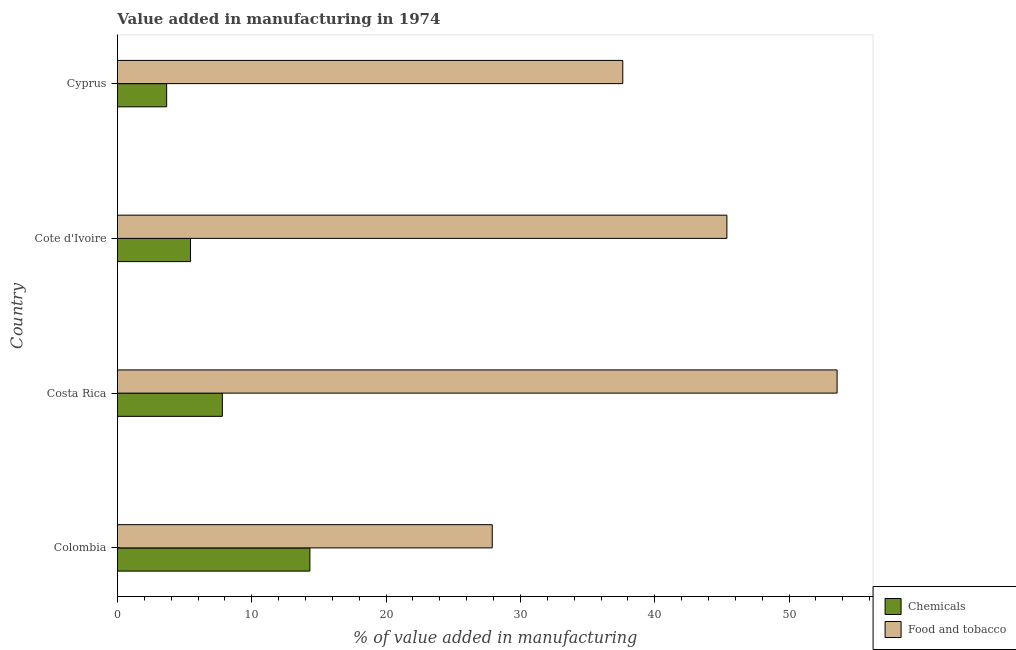How many groups of bars are there?
Your answer should be very brief. 4. Are the number of bars per tick equal to the number of legend labels?
Offer a terse response. Yes. How many bars are there on the 2nd tick from the top?
Your answer should be very brief. 2. How many bars are there on the 2nd tick from the bottom?
Provide a succinct answer. 2. What is the label of the 4th group of bars from the top?
Keep it short and to the point. Colombia. What is the value added by manufacturing food and tobacco in Cote d'Ivoire?
Provide a succinct answer. 45.37. Across all countries, what is the maximum value added by  manufacturing chemicals?
Provide a succinct answer. 14.33. Across all countries, what is the minimum value added by manufacturing food and tobacco?
Keep it short and to the point. 27.9. What is the total value added by  manufacturing chemicals in the graph?
Provide a short and direct response. 31.25. What is the difference between the value added by  manufacturing chemicals in Colombia and that in Costa Rica?
Give a very brief answer. 6.52. What is the difference between the value added by manufacturing food and tobacco in Costa Rica and the value added by  manufacturing chemicals in Cote d'Ivoire?
Your answer should be very brief. 48.13. What is the average value added by manufacturing food and tobacco per country?
Your response must be concise. 41.11. What is the difference between the value added by  manufacturing chemicals and value added by manufacturing food and tobacco in Cyprus?
Offer a very short reply. -33.95. What is the ratio of the value added by manufacturing food and tobacco in Cote d'Ivoire to that in Cyprus?
Keep it short and to the point. 1.21. Is the difference between the value added by  manufacturing chemicals in Colombia and Costa Rica greater than the difference between the value added by manufacturing food and tobacco in Colombia and Costa Rica?
Ensure brevity in your answer.  Yes. What is the difference between the highest and the second highest value added by  manufacturing chemicals?
Make the answer very short. 6.52. What is the difference between the highest and the lowest value added by manufacturing food and tobacco?
Your response must be concise. 25.67. Is the sum of the value added by  manufacturing chemicals in Cote d'Ivoire and Cyprus greater than the maximum value added by manufacturing food and tobacco across all countries?
Ensure brevity in your answer.  No. What does the 2nd bar from the top in Costa Rica represents?
Your answer should be compact. Chemicals. What does the 1st bar from the bottom in Costa Rica represents?
Keep it short and to the point. Chemicals. How many bars are there?
Provide a short and direct response. 8. Are all the bars in the graph horizontal?
Your response must be concise. Yes. How many countries are there in the graph?
Ensure brevity in your answer.  4. What is the difference between two consecutive major ticks on the X-axis?
Your response must be concise. 10. Does the graph contain any zero values?
Keep it short and to the point. No. How many legend labels are there?
Your answer should be very brief. 2. How are the legend labels stacked?
Offer a terse response. Vertical. What is the title of the graph?
Offer a very short reply. Value added in manufacturing in 1974. What is the label or title of the X-axis?
Your response must be concise. % of value added in manufacturing. What is the % of value added in manufacturing in Chemicals in Colombia?
Your response must be concise. 14.33. What is the % of value added in manufacturing of Food and tobacco in Colombia?
Your response must be concise. 27.9. What is the % of value added in manufacturing in Chemicals in Costa Rica?
Provide a succinct answer. 7.81. What is the % of value added in manufacturing in Food and tobacco in Costa Rica?
Offer a terse response. 53.57. What is the % of value added in manufacturing of Chemicals in Cote d'Ivoire?
Your response must be concise. 5.44. What is the % of value added in manufacturing of Food and tobacco in Cote d'Ivoire?
Make the answer very short. 45.37. What is the % of value added in manufacturing of Chemicals in Cyprus?
Offer a terse response. 3.67. What is the % of value added in manufacturing in Food and tobacco in Cyprus?
Your response must be concise. 37.62. Across all countries, what is the maximum % of value added in manufacturing of Chemicals?
Offer a very short reply. 14.33. Across all countries, what is the maximum % of value added in manufacturing in Food and tobacco?
Your answer should be very brief. 53.57. Across all countries, what is the minimum % of value added in manufacturing in Chemicals?
Offer a terse response. 3.67. Across all countries, what is the minimum % of value added in manufacturing of Food and tobacco?
Your answer should be very brief. 27.9. What is the total % of value added in manufacturing of Chemicals in the graph?
Give a very brief answer. 31.25. What is the total % of value added in manufacturing in Food and tobacco in the graph?
Your answer should be compact. 164.46. What is the difference between the % of value added in manufacturing in Chemicals in Colombia and that in Costa Rica?
Your answer should be compact. 6.52. What is the difference between the % of value added in manufacturing in Food and tobacco in Colombia and that in Costa Rica?
Provide a short and direct response. -25.67. What is the difference between the % of value added in manufacturing in Chemicals in Colombia and that in Cote d'Ivoire?
Your response must be concise. 8.89. What is the difference between the % of value added in manufacturing in Food and tobacco in Colombia and that in Cote d'Ivoire?
Make the answer very short. -17.47. What is the difference between the % of value added in manufacturing in Chemicals in Colombia and that in Cyprus?
Make the answer very short. 10.66. What is the difference between the % of value added in manufacturing of Food and tobacco in Colombia and that in Cyprus?
Your answer should be very brief. -9.72. What is the difference between the % of value added in manufacturing in Chemicals in Costa Rica and that in Cote d'Ivoire?
Keep it short and to the point. 2.37. What is the difference between the % of value added in manufacturing of Food and tobacco in Costa Rica and that in Cote d'Ivoire?
Provide a short and direct response. 8.2. What is the difference between the % of value added in manufacturing in Chemicals in Costa Rica and that in Cyprus?
Your response must be concise. 4.15. What is the difference between the % of value added in manufacturing of Food and tobacco in Costa Rica and that in Cyprus?
Your answer should be compact. 15.95. What is the difference between the % of value added in manufacturing in Chemicals in Cote d'Ivoire and that in Cyprus?
Offer a very short reply. 1.78. What is the difference between the % of value added in manufacturing in Food and tobacco in Cote d'Ivoire and that in Cyprus?
Keep it short and to the point. 7.75. What is the difference between the % of value added in manufacturing of Chemicals in Colombia and the % of value added in manufacturing of Food and tobacco in Costa Rica?
Offer a terse response. -39.24. What is the difference between the % of value added in manufacturing in Chemicals in Colombia and the % of value added in manufacturing in Food and tobacco in Cote d'Ivoire?
Ensure brevity in your answer.  -31.04. What is the difference between the % of value added in manufacturing of Chemicals in Colombia and the % of value added in manufacturing of Food and tobacco in Cyprus?
Offer a terse response. -23.29. What is the difference between the % of value added in manufacturing of Chemicals in Costa Rica and the % of value added in manufacturing of Food and tobacco in Cote d'Ivoire?
Your answer should be very brief. -37.56. What is the difference between the % of value added in manufacturing in Chemicals in Costa Rica and the % of value added in manufacturing in Food and tobacco in Cyprus?
Provide a short and direct response. -29.81. What is the difference between the % of value added in manufacturing of Chemicals in Cote d'Ivoire and the % of value added in manufacturing of Food and tobacco in Cyprus?
Your answer should be compact. -32.18. What is the average % of value added in manufacturing in Chemicals per country?
Your response must be concise. 7.81. What is the average % of value added in manufacturing in Food and tobacco per country?
Give a very brief answer. 41.11. What is the difference between the % of value added in manufacturing of Chemicals and % of value added in manufacturing of Food and tobacco in Colombia?
Your answer should be compact. -13.57. What is the difference between the % of value added in manufacturing of Chemicals and % of value added in manufacturing of Food and tobacco in Costa Rica?
Make the answer very short. -45.76. What is the difference between the % of value added in manufacturing of Chemicals and % of value added in manufacturing of Food and tobacco in Cote d'Ivoire?
Your answer should be compact. -39.93. What is the difference between the % of value added in manufacturing of Chemicals and % of value added in manufacturing of Food and tobacco in Cyprus?
Your response must be concise. -33.95. What is the ratio of the % of value added in manufacturing in Chemicals in Colombia to that in Costa Rica?
Your answer should be very brief. 1.83. What is the ratio of the % of value added in manufacturing in Food and tobacco in Colombia to that in Costa Rica?
Offer a terse response. 0.52. What is the ratio of the % of value added in manufacturing in Chemicals in Colombia to that in Cote d'Ivoire?
Ensure brevity in your answer.  2.63. What is the ratio of the % of value added in manufacturing of Food and tobacco in Colombia to that in Cote d'Ivoire?
Your answer should be compact. 0.61. What is the ratio of the % of value added in manufacturing in Chemicals in Colombia to that in Cyprus?
Give a very brief answer. 3.91. What is the ratio of the % of value added in manufacturing in Food and tobacco in Colombia to that in Cyprus?
Offer a very short reply. 0.74. What is the ratio of the % of value added in manufacturing in Chemicals in Costa Rica to that in Cote d'Ivoire?
Your response must be concise. 1.44. What is the ratio of the % of value added in manufacturing in Food and tobacco in Costa Rica to that in Cote d'Ivoire?
Your response must be concise. 1.18. What is the ratio of the % of value added in manufacturing in Chemicals in Costa Rica to that in Cyprus?
Make the answer very short. 2.13. What is the ratio of the % of value added in manufacturing of Food and tobacco in Costa Rica to that in Cyprus?
Keep it short and to the point. 1.42. What is the ratio of the % of value added in manufacturing of Chemicals in Cote d'Ivoire to that in Cyprus?
Offer a very short reply. 1.48. What is the ratio of the % of value added in manufacturing in Food and tobacco in Cote d'Ivoire to that in Cyprus?
Keep it short and to the point. 1.21. What is the difference between the highest and the second highest % of value added in manufacturing of Chemicals?
Provide a short and direct response. 6.52. What is the difference between the highest and the second highest % of value added in manufacturing of Food and tobacco?
Offer a very short reply. 8.2. What is the difference between the highest and the lowest % of value added in manufacturing of Chemicals?
Provide a short and direct response. 10.66. What is the difference between the highest and the lowest % of value added in manufacturing of Food and tobacco?
Ensure brevity in your answer.  25.67. 